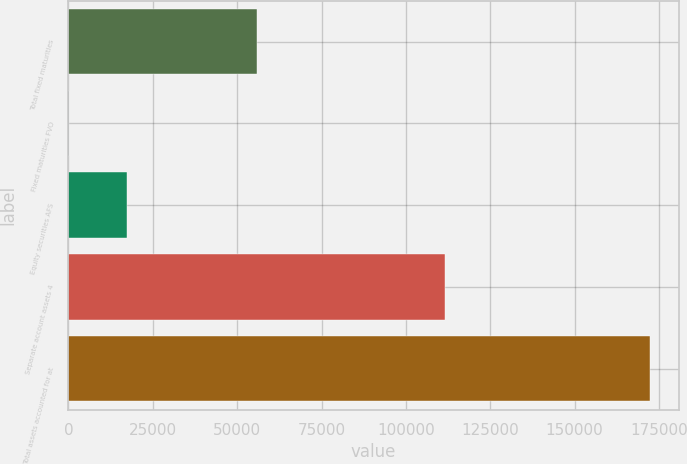<chart> <loc_0><loc_0><loc_500><loc_500><bar_chart><fcel>Total fixed maturities<fcel>Fixed maturities FVO<fcel>Equity securities AFS<fcel>Separate account assets 4<fcel>Total assets accounted for at<nl><fcel>56003<fcel>293<fcel>17488<fcel>111634<fcel>172243<nl></chart> 